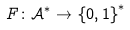<formula> <loc_0><loc_0><loc_500><loc_500>F \colon \mathcal { A } ^ { \ast } \rightarrow \left \{ 0 , 1 \right \} ^ { \ast }</formula> 